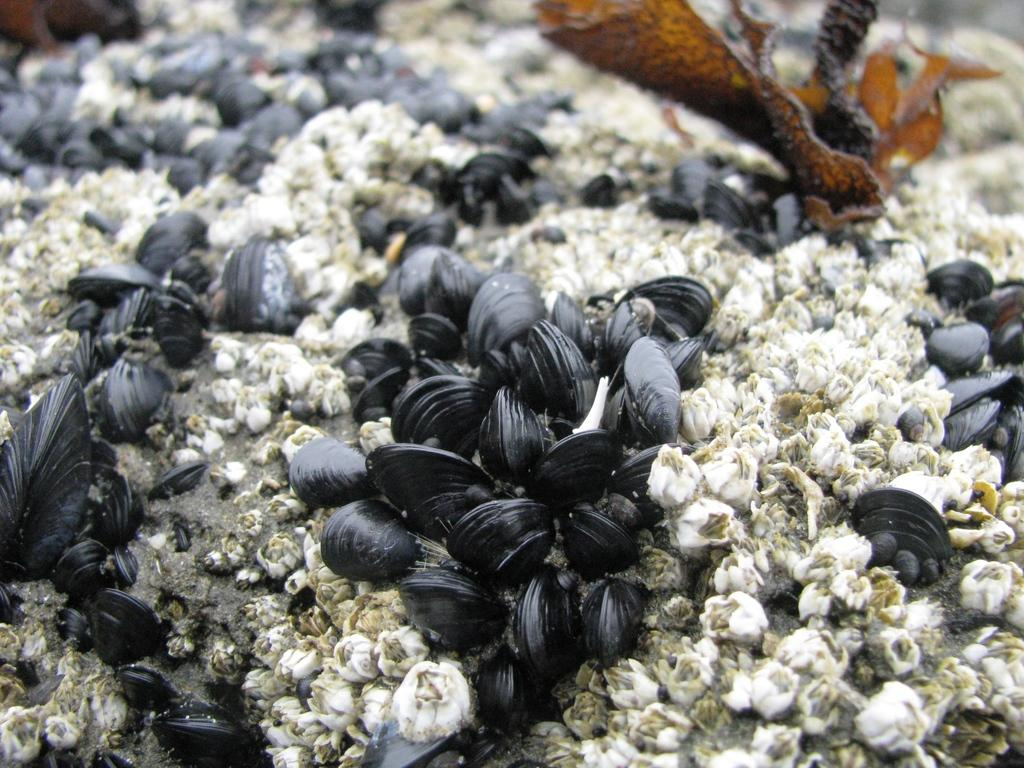What is the main subject of the image? The main subject of the image is a group of shells. What color are the objects in the image? There are white objects in the image. Can you describe any other objects in the image besides the shells? There is a brown object that looks like a leaf in the image. How many units of light can be seen in the image? There is no mention of units of light in the image, as it primarily features shells and a brown object that looks like a leaf. 